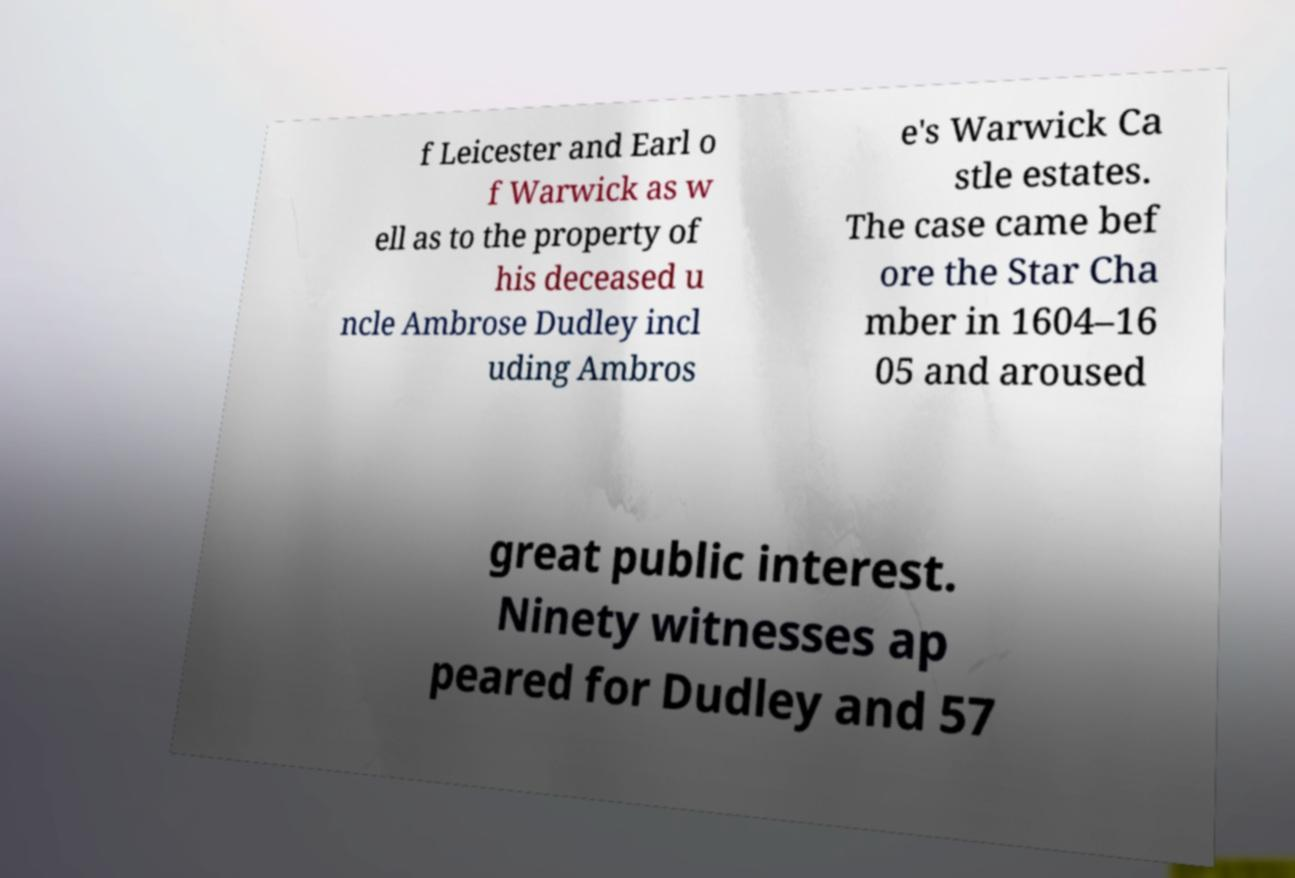Please read and relay the text visible in this image. What does it say? f Leicester and Earl o f Warwick as w ell as to the property of his deceased u ncle Ambrose Dudley incl uding Ambros e's Warwick Ca stle estates. The case came bef ore the Star Cha mber in 1604–16 05 and aroused great public interest. Ninety witnesses ap peared for Dudley and 57 